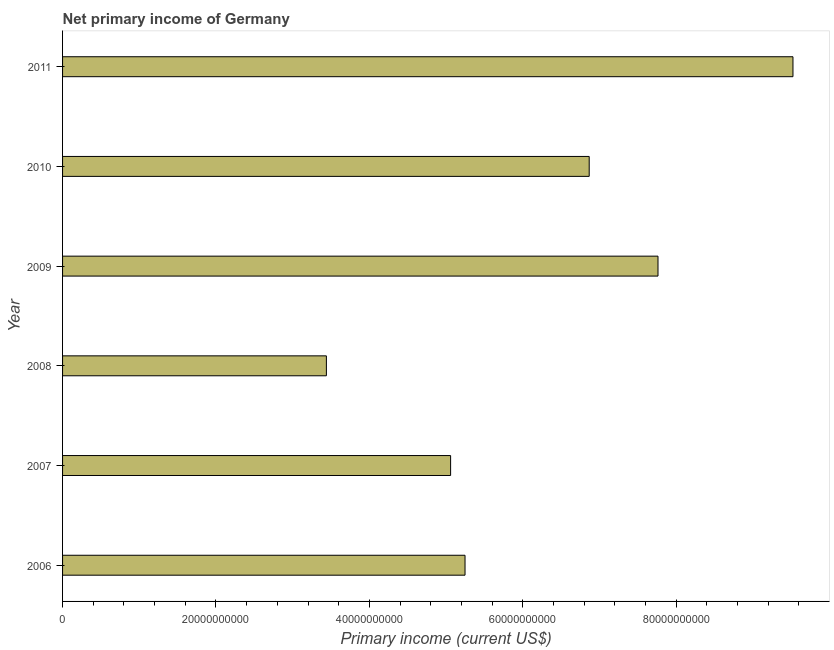Does the graph contain any zero values?
Offer a terse response. No. What is the title of the graph?
Your answer should be compact. Net primary income of Germany. What is the label or title of the X-axis?
Give a very brief answer. Primary income (current US$). What is the label or title of the Y-axis?
Offer a terse response. Year. What is the amount of primary income in 2009?
Provide a short and direct response. 7.76e+1. Across all years, what is the maximum amount of primary income?
Your answer should be compact. 9.52e+1. Across all years, what is the minimum amount of primary income?
Your answer should be compact. 3.44e+1. In which year was the amount of primary income maximum?
Offer a very short reply. 2011. What is the sum of the amount of primary income?
Your answer should be very brief. 3.79e+11. What is the difference between the amount of primary income in 2007 and 2011?
Your response must be concise. -4.46e+1. What is the average amount of primary income per year?
Offer a very short reply. 6.32e+1. What is the median amount of primary income?
Ensure brevity in your answer.  6.06e+1. What is the ratio of the amount of primary income in 2006 to that in 2008?
Keep it short and to the point. 1.52. What is the difference between the highest and the second highest amount of primary income?
Keep it short and to the point. 1.76e+1. What is the difference between the highest and the lowest amount of primary income?
Offer a very short reply. 6.08e+1. In how many years, is the amount of primary income greater than the average amount of primary income taken over all years?
Offer a very short reply. 3. Are all the bars in the graph horizontal?
Provide a succinct answer. Yes. What is the Primary income (current US$) in 2006?
Your answer should be compact. 5.25e+1. What is the Primary income (current US$) in 2007?
Your response must be concise. 5.06e+1. What is the Primary income (current US$) in 2008?
Your answer should be compact. 3.44e+1. What is the Primary income (current US$) of 2009?
Your answer should be very brief. 7.76e+1. What is the Primary income (current US$) of 2010?
Offer a terse response. 6.87e+1. What is the Primary income (current US$) of 2011?
Your response must be concise. 9.52e+1. What is the difference between the Primary income (current US$) in 2006 and 2007?
Your answer should be very brief. 1.88e+09. What is the difference between the Primary income (current US$) in 2006 and 2008?
Give a very brief answer. 1.81e+1. What is the difference between the Primary income (current US$) in 2006 and 2009?
Keep it short and to the point. -2.52e+1. What is the difference between the Primary income (current US$) in 2006 and 2010?
Provide a succinct answer. -1.62e+1. What is the difference between the Primary income (current US$) in 2006 and 2011?
Ensure brevity in your answer.  -4.28e+1. What is the difference between the Primary income (current US$) in 2007 and 2008?
Keep it short and to the point. 1.62e+1. What is the difference between the Primary income (current US$) in 2007 and 2009?
Your response must be concise. -2.70e+1. What is the difference between the Primary income (current US$) in 2007 and 2010?
Keep it short and to the point. -1.81e+1. What is the difference between the Primary income (current US$) in 2007 and 2011?
Ensure brevity in your answer.  -4.46e+1. What is the difference between the Primary income (current US$) in 2008 and 2009?
Make the answer very short. -4.32e+1. What is the difference between the Primary income (current US$) in 2008 and 2010?
Keep it short and to the point. -3.43e+1. What is the difference between the Primary income (current US$) in 2008 and 2011?
Provide a short and direct response. -6.08e+1. What is the difference between the Primary income (current US$) in 2009 and 2010?
Provide a succinct answer. 8.97e+09. What is the difference between the Primary income (current US$) in 2009 and 2011?
Make the answer very short. -1.76e+1. What is the difference between the Primary income (current US$) in 2010 and 2011?
Offer a very short reply. -2.66e+1. What is the ratio of the Primary income (current US$) in 2006 to that in 2008?
Ensure brevity in your answer.  1.52. What is the ratio of the Primary income (current US$) in 2006 to that in 2009?
Provide a succinct answer. 0.68. What is the ratio of the Primary income (current US$) in 2006 to that in 2010?
Provide a succinct answer. 0.76. What is the ratio of the Primary income (current US$) in 2006 to that in 2011?
Provide a succinct answer. 0.55. What is the ratio of the Primary income (current US$) in 2007 to that in 2008?
Offer a terse response. 1.47. What is the ratio of the Primary income (current US$) in 2007 to that in 2009?
Give a very brief answer. 0.65. What is the ratio of the Primary income (current US$) in 2007 to that in 2010?
Offer a terse response. 0.74. What is the ratio of the Primary income (current US$) in 2007 to that in 2011?
Your answer should be very brief. 0.53. What is the ratio of the Primary income (current US$) in 2008 to that in 2009?
Make the answer very short. 0.44. What is the ratio of the Primary income (current US$) in 2008 to that in 2010?
Your answer should be compact. 0.5. What is the ratio of the Primary income (current US$) in 2008 to that in 2011?
Make the answer very short. 0.36. What is the ratio of the Primary income (current US$) in 2009 to that in 2010?
Your answer should be very brief. 1.13. What is the ratio of the Primary income (current US$) in 2009 to that in 2011?
Your response must be concise. 0.81. What is the ratio of the Primary income (current US$) in 2010 to that in 2011?
Offer a terse response. 0.72. 